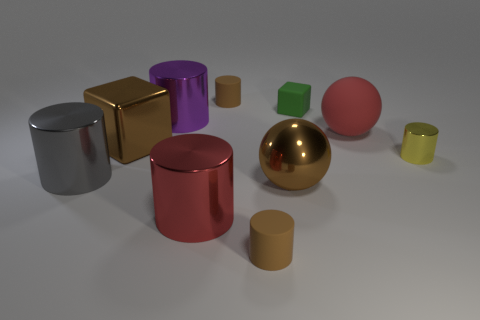There is a large thing that is the same color as the large block; what shape is it?
Provide a short and direct response. Sphere. Is the size of the red ball the same as the brown object on the left side of the big purple thing?
Provide a succinct answer. Yes. There is a block behind the brown metallic object that is behind the big gray cylinder; how many small brown matte cylinders are behind it?
Offer a terse response. 1. What size is the metal object that is the same color as the shiny ball?
Your answer should be compact. Large. There is a big purple metal thing; are there any tiny brown matte cylinders on the left side of it?
Give a very brief answer. No. What is the shape of the red shiny object?
Your answer should be compact. Cylinder. The small brown rubber object right of the small brown rubber object behind the small cylinder that is in front of the yellow thing is what shape?
Your response must be concise. Cylinder. How many other objects are there of the same shape as the yellow metallic object?
Provide a short and direct response. 5. What material is the small brown object that is to the right of the cylinder that is behind the purple cylinder?
Make the answer very short. Rubber. Are there any other things that have the same size as the brown cube?
Your answer should be very brief. Yes. 